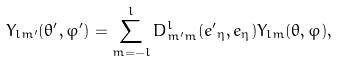<formula> <loc_0><loc_0><loc_500><loc_500>Y _ { l m ^ { \prime } } ( \theta ^ { \prime } , \varphi ^ { \prime } ) = \sum _ { m = - l } ^ { l } D ^ { l } _ { m ^ { \prime } m } ( { e ^ { \prime } } _ { \eta } , { e } _ { \eta } ) Y _ { l m } ( \theta , \varphi ) ,</formula> 